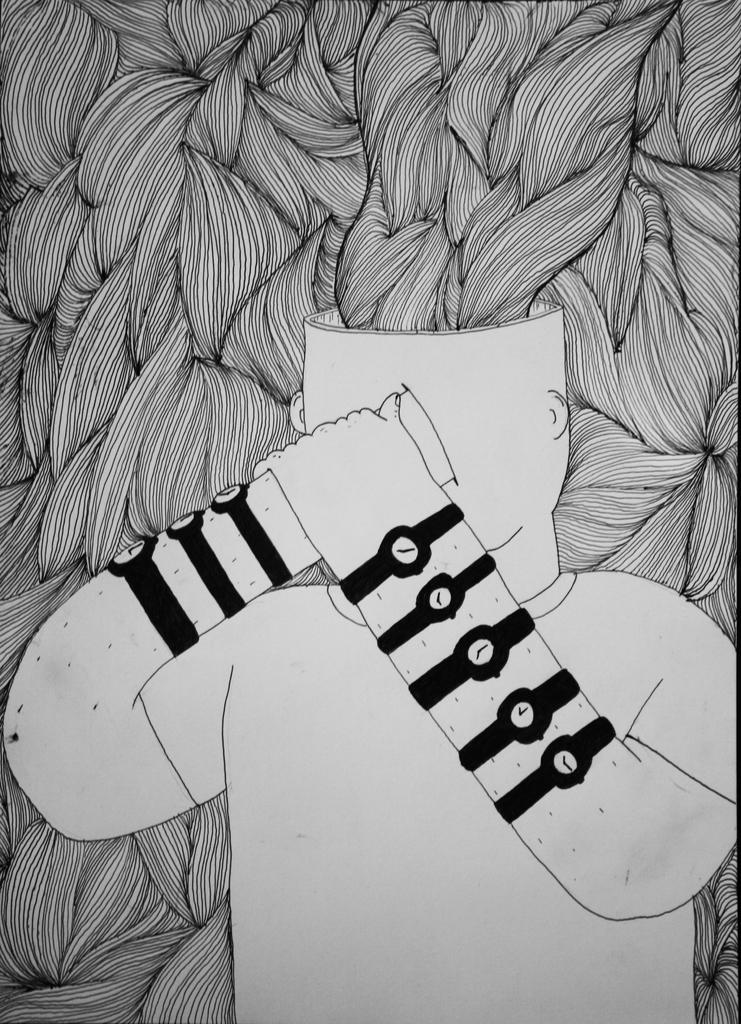What is depicted in the image? There is a drawing in the image. What is the main subject of the drawing? The drawing features a person. What is the person doing in the drawing? The person is placing one hand on their head, and another hand is on the person's hand on their head. What can be seen in the background of the drawing? There is a design in the background of the drawing. How many birds are flying in the image? There are no birds present in the image; it features a drawing of a person with a specific pose and a background design. 